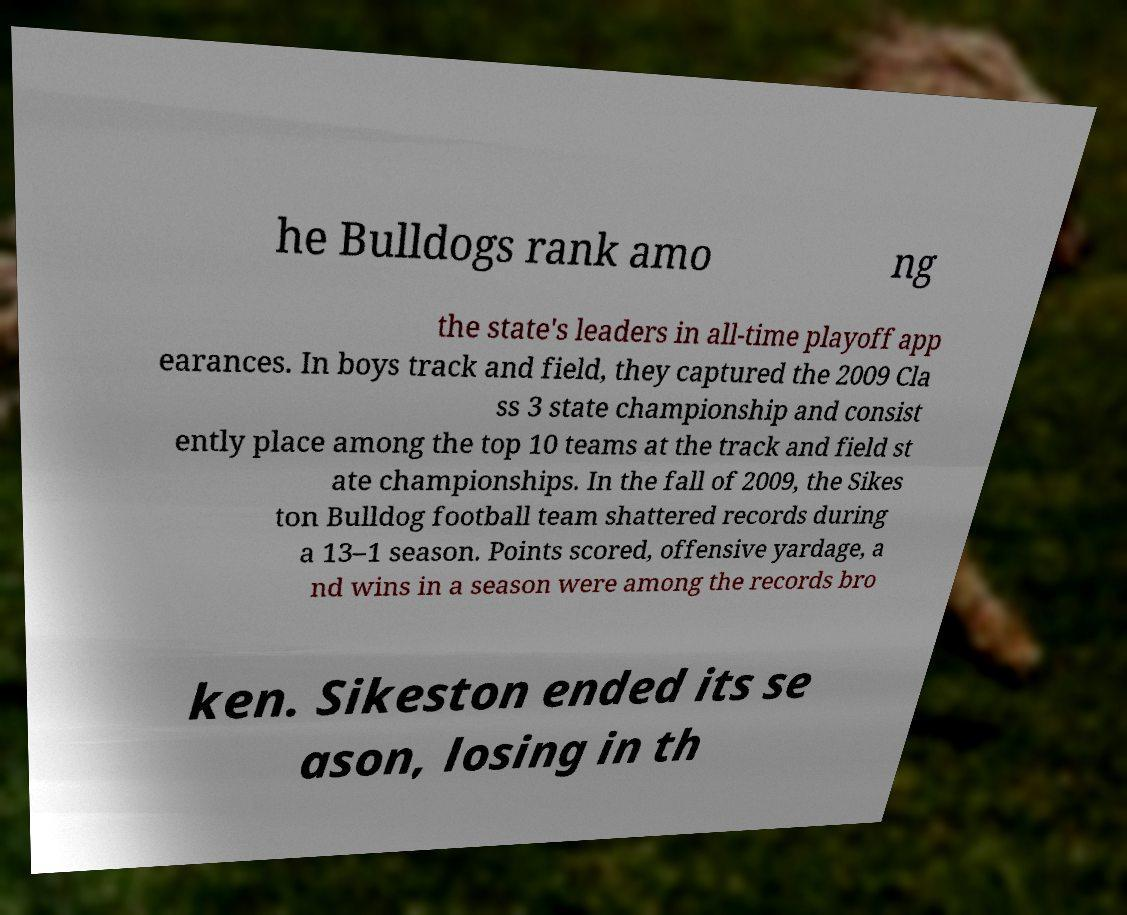Can you accurately transcribe the text from the provided image for me? he Bulldogs rank amo ng the state's leaders in all-time playoff app earances. In boys track and field, they captured the 2009 Cla ss 3 state championship and consist ently place among the top 10 teams at the track and field st ate championships. In the fall of 2009, the Sikes ton Bulldog football team shattered records during a 13–1 season. Points scored, offensive yardage, a nd wins in a season were among the records bro ken. Sikeston ended its se ason, losing in th 